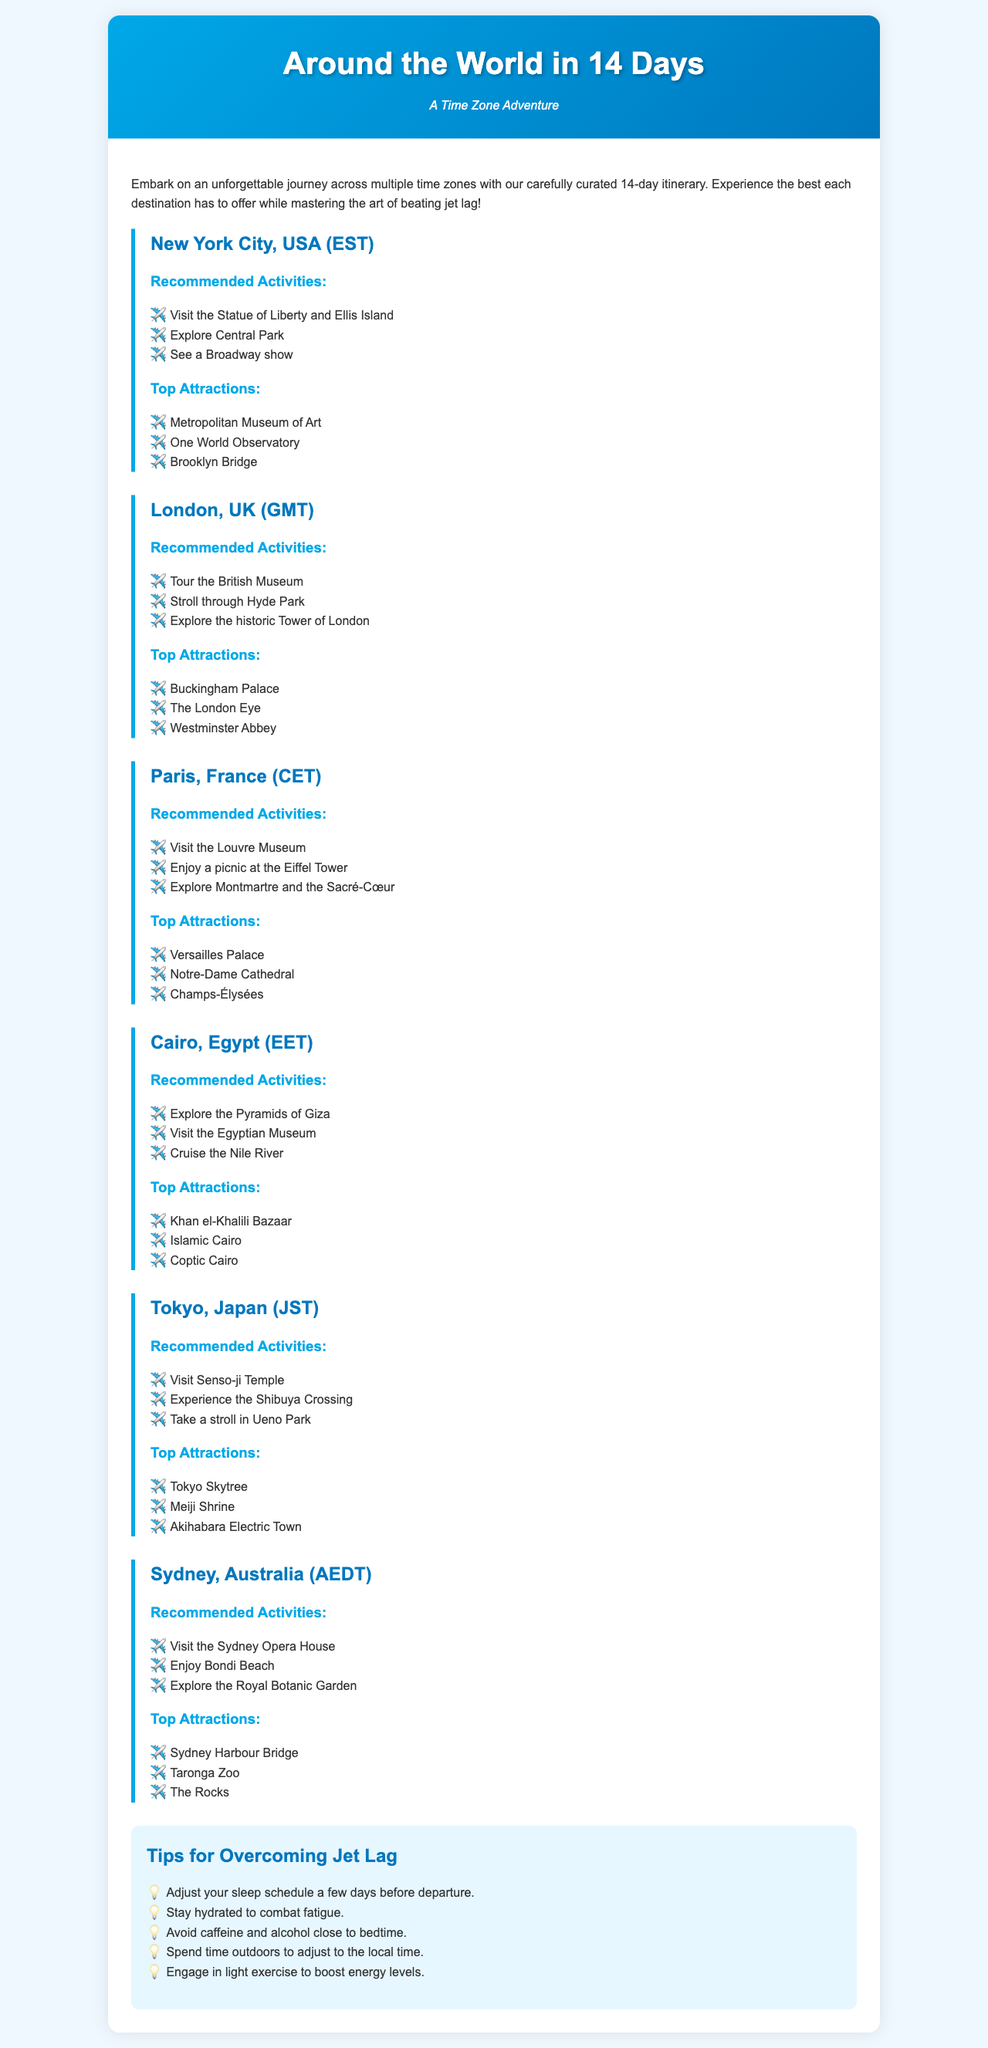What is the first destination in the itinerary? The first destination listed is New York City, USA.
Answer: New York City, USA How many recommended activities are listed for Paris? The document lists three recommended activities for Paris.
Answer: 3 What time zone is Tokyo in? The document states that Tokyo is in the JST time zone.
Answer: JST Which attraction is included in both Sydney and New York City sections? The document does not list any attractions included in both sections; they are unique to each location.
Answer: None What is one tip provided for overcoming jet lag? The document offers multiple tips for overcoming jet lag, one of which is to adjust your sleep schedule a few days before departure.
Answer: Adjust your sleep schedule a few days before departure What is the total number of destinations mentioned in the itinerary? The document mentions a total of six destinations throughout the itinerary.
Answer: 6 Which city features the Eiffel Tower? The city featuring the Eiffel Tower is Paris, as mentioned in the document.
Answer: Paris What activity can you do in Cairo? One activity listed for Cairo is to explore the Pyramids of Giza.
Answer: Explore the Pyramids of Giza 